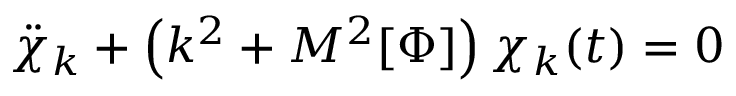<formula> <loc_0><loc_0><loc_500><loc_500>{ \ddot { \chi } } _ { k } + \left ( { k ^ { 2 } } + M ^ { 2 } [ \Phi ] \right ) \chi _ { k } ( t ) = 0</formula> 